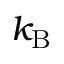<formula> <loc_0><loc_0><loc_500><loc_500>k _ { B }</formula> 